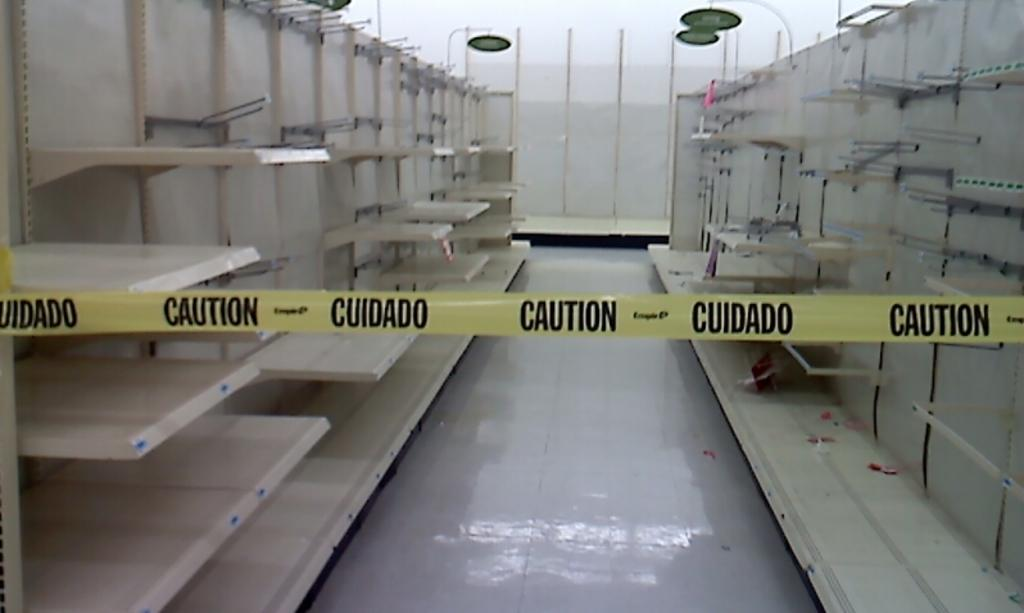What is the main subject in the center of the image? There is a construction safety tag in the center of the image. What can be seen on the left side of the image? There are shelves on the left side of the image. What can be seen on the right side of the image? There are shelves on the right side of the image. What is visible in the background of the image? There is a wall in the background of the image. Where is the mom standing in the image? There is no mom present in the image. How many cows are visible in the image? There are no cows visible in the image. 